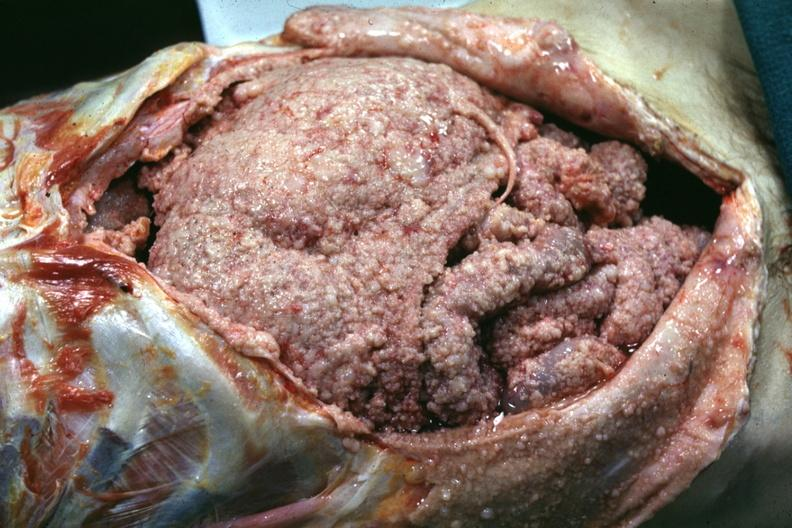what is present?
Answer the question using a single word or phrase. Mesothelioma 